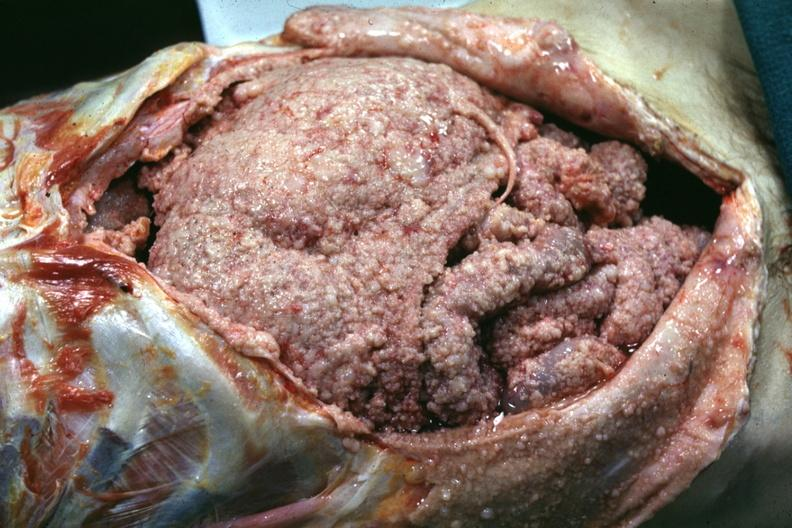what is present?
Answer the question using a single word or phrase. Mesothelioma 